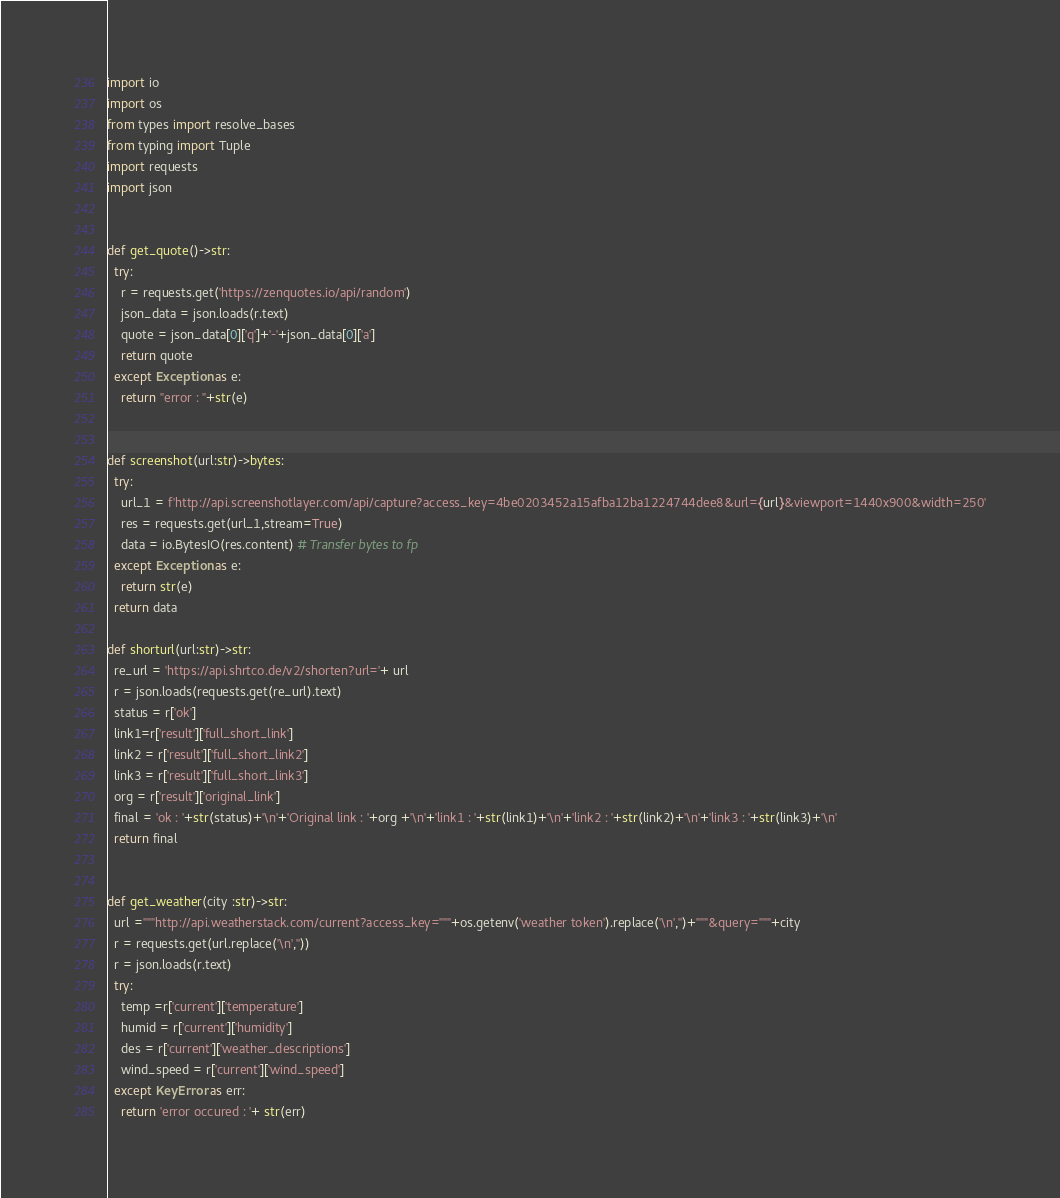<code> <loc_0><loc_0><loc_500><loc_500><_Python_>import io
import os
from types import resolve_bases
from typing import Tuple
import requests
import json


def get_quote()->str:
  try:
    r = requests.get('https://zenquotes.io/api/random')
    json_data = json.loads(r.text)
    quote = json_data[0]['q']+'-'+json_data[0]['a']
    return quote
  except Exception as e:
    return "error : "+str(e)


def screenshot(url:str)->bytes:
  try:
    url_1 = f'http://api.screenshotlayer.com/api/capture?access_key=4be0203452a15afba12ba1224744dee8&url={url}&viewport=1440x900&width=250'
    res = requests.get(url_1,stream=True)
    data = io.BytesIO(res.content) # Transfer bytes to fp
  except Exception as e:
    return str(e)
  return data

def shorturl(url:str)->str:
  re_url = 'https://api.shrtco.de/v2/shorten?url='+ url
  r = json.loads(requests.get(re_url).text)
  status = r['ok']
  link1=r['result']['full_short_link']
  link2 = r['result']['full_short_link2']
  link3 = r['result']['full_short_link3']
  org = r['result']['original_link']
  final = 'ok : '+str(status)+'\n'+'Original link : '+org +'\n'+'link1 : '+str(link1)+'\n'+'link2 : '+str(link2)+'\n'+'link3 : '+str(link3)+'\n'
  return final


def get_weather(city :str)->str:
  url ="""http://api.weatherstack.com/current?access_key="""+os.getenv('weather token').replace('\n','')+"""&query="""+city
  r = requests.get(url.replace('\n',''))
  r = json.loads(r.text)
  try:
    temp =r['current']['temperature']
    humid = r['current']['humidity']
    des = r['current']['weather_descriptions']
    wind_speed = r['current']['wind_speed']
  except KeyError as err:
    return 'error occured : '+ str(err)</code> 